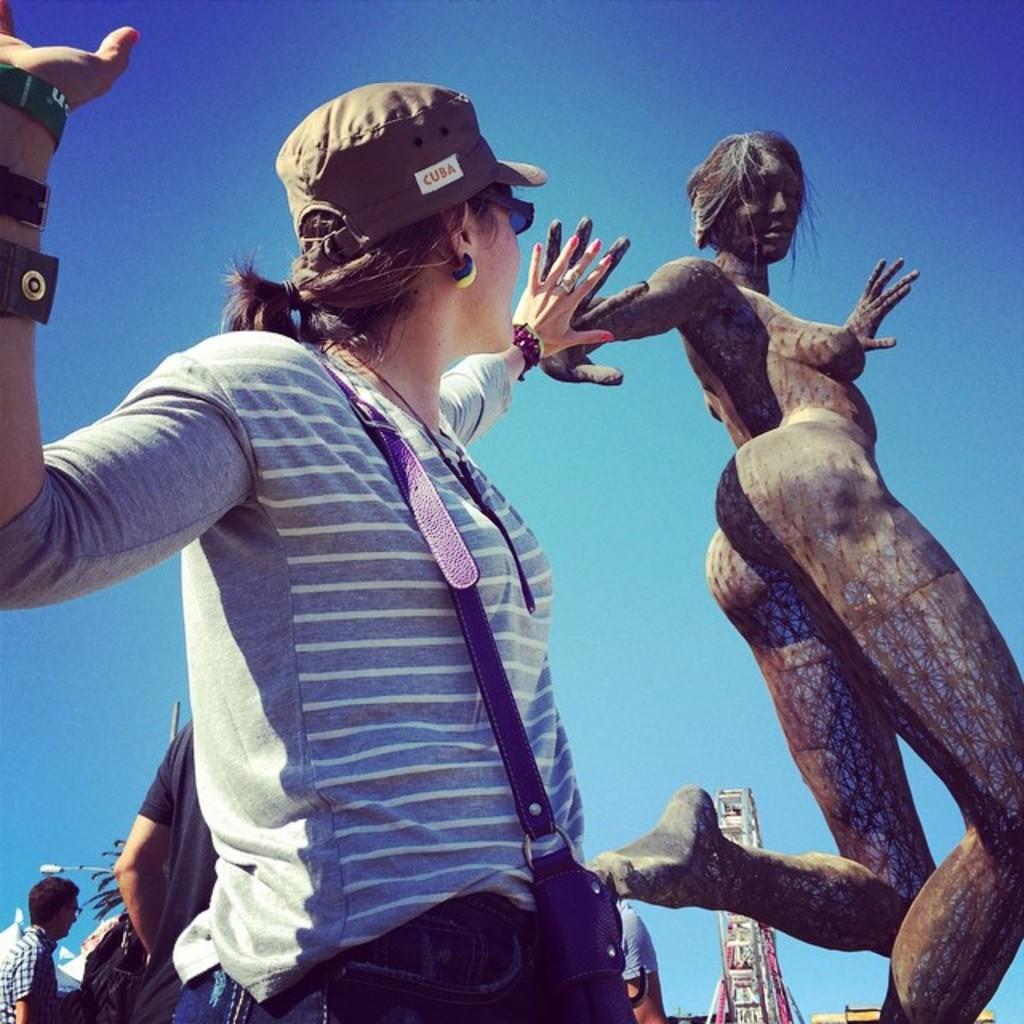Can you describe this image briefly? In this image we can see group of people standing on the ground. A women is wearing a bag ,cap and goggles is staring at a statue of a women. In the background we can see a Ferris wheel ,pole ,tree and sky. 